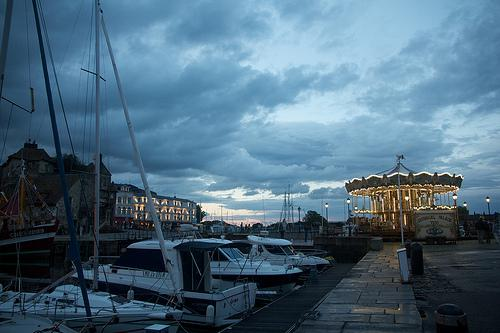Question: what time of day is it?
Choices:
A. Dawn.
B. Dusk.
C. Evening.
D. Midnight.
Answer with the letter. Answer: B Question: how can you tell it's dark?
Choices:
A. No lights are on.
B. The sun is gone.
C. The lights are on.
D. The moon is out.
Answer with the letter. Answer: C Question: what are is the dock made of?
Choices:
A. Rubber.
B. Metal.
C. Wood.
D. Plastic.
Answer with the letter. Answer: C Question: where is another house?
Choices:
A. Up the path.
B. To the left of the dock.
C. Across the street.
D. By the water.
Answer with the letter. Answer: B Question: where are the street lights?
Choices:
A. Lined up behind the carousel.
B. On the side of the street.
C. In front of the last house.
D. On the corner.
Answer with the letter. Answer: A 